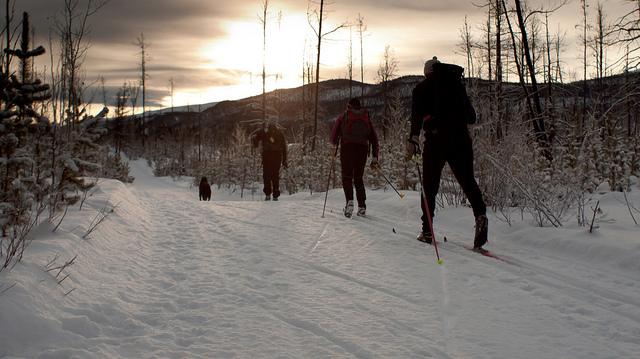Is there horses in this picture?
Give a very brief answer. No. Is it snowing?
Write a very short answer. No. Are they skiing?
Quick response, please. Yes. Will these skiers make it back before the sun goes down?
Quick response, please. No. How many people are walking?
Short answer required. 4. 